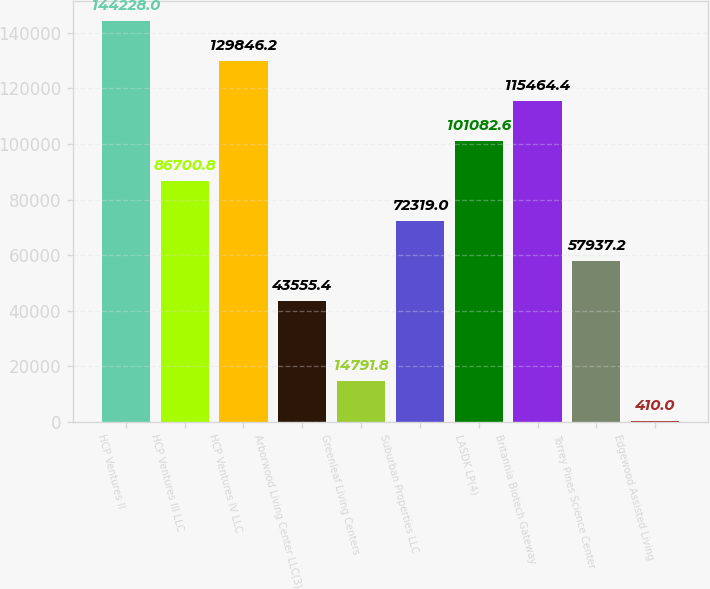Convert chart. <chart><loc_0><loc_0><loc_500><loc_500><bar_chart><fcel>HCP Ventures II<fcel>HCP Ventures III LLC<fcel>HCP Ventures IV LLC<fcel>Arborwood Living Center LLC(3)<fcel>Greenleaf Living Centers<fcel>Suburban Properties LLC<fcel>LASDK LP(4)<fcel>Britannia Biotech Gateway<fcel>Torrey Pines Science Center<fcel>Edgewood Assisted Living<nl><fcel>144228<fcel>86700.8<fcel>129846<fcel>43555.4<fcel>14791.8<fcel>72319<fcel>101083<fcel>115464<fcel>57937.2<fcel>410<nl></chart> 